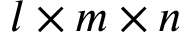Convert formula to latex. <formula><loc_0><loc_0><loc_500><loc_500>l \times m \times n</formula> 